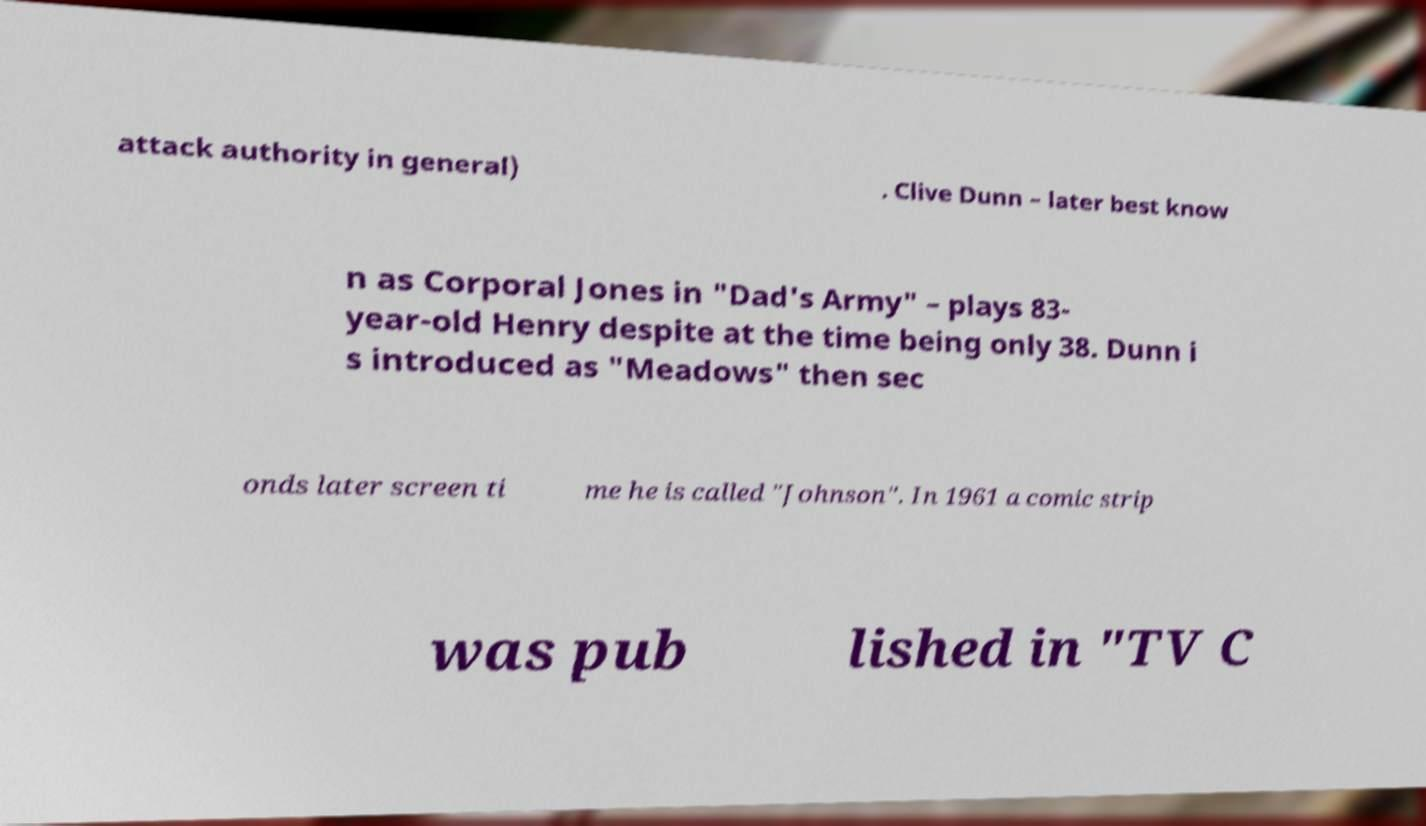Please read and relay the text visible in this image. What does it say? attack authority in general) . Clive Dunn – later best know n as Corporal Jones in "Dad's Army" – plays 83- year-old Henry despite at the time being only 38. Dunn i s introduced as "Meadows" then sec onds later screen ti me he is called "Johnson". In 1961 a comic strip was pub lished in "TV C 